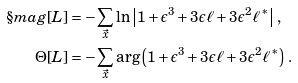<formula> <loc_0><loc_0><loc_500><loc_500>\S m a g [ L ] & = - \sum _ { \vec { x } } \ln \left | 1 + \epsilon ^ { 3 } + 3 \epsilon \ell + 3 \epsilon ^ { 2 } \ell ^ { \ast } \right | \, , \\ \Theta [ L ] & = - \sum _ { \vec { x } } \arg \left ( 1 + \epsilon ^ { 3 } + 3 \epsilon \ell + 3 \epsilon ^ { 2 } \ell ^ { \ast } \right ) \, .</formula> 